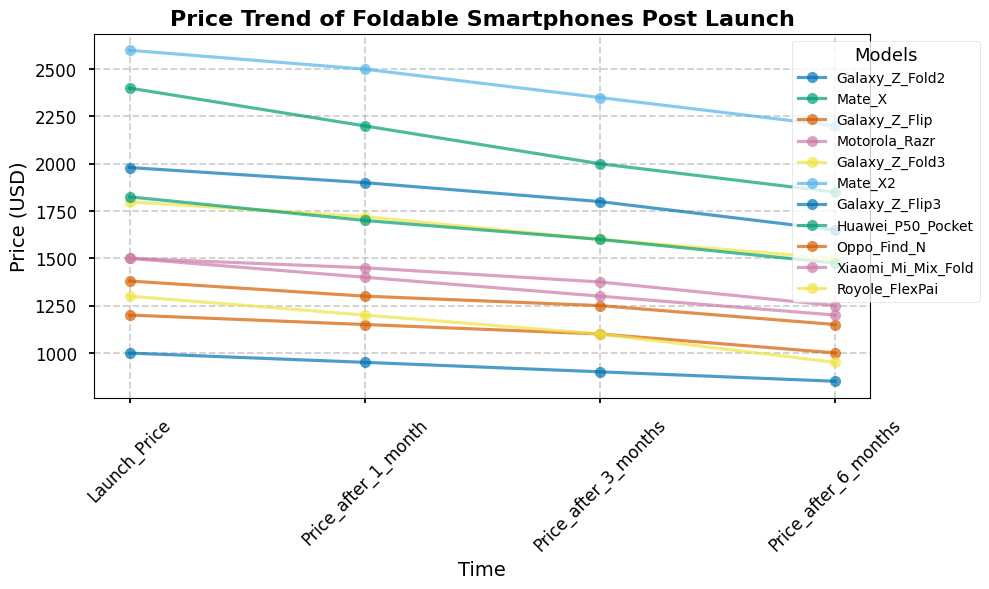Which model shows the highest initial launch price? Observe the launch price on the y-axis and find the model with the maximum value. In this case, "Mate X2" has the highest initial launch price at 2600 USD.
Answer: Mate X2 Comparing "Galaxy Z Fold2" and "Galaxy Z Fold3", which one shows a greater price decrease after 6 months? Calculate the difference in the launch price and price after 6 months for both models. "Galaxy Z Fold2" decreases from 1980 to 1650, a drop of 330 USD. "Galaxy Z Fold3" decreases from 1799 to 1500, a drop of 299 USD. Thus, "Galaxy Z Fold2" shows a greater price decrease.
Answer: Galaxy Z Fold2 What is the average price of "Motorola Razr" and "Royole FlexPai" after 3 months? Add the 3-month prices of both models and divide by 2. "Motorola Razr" is 1300 and "Royole FlexPai" is 1100; (1300 + 1100) / 2 = 1200 USD is the average price.
Answer: 1200 USD Which model exhibits the steepest price drop after 1 month? Determine the price drop for each model after 1 month and find the biggest value. "Mate X" drops from 2400 to 2200, a 200 USD decrease, which is one of the largest drops.
Answer: Mate X How does the price drop of "Oppo Find N" after 6 months compare to "Xiaomi Mi Mix Fold" after 6 months? Calculate the 6-month price drop for both models: "Oppo Find N" drops from 1200 to 1000 (200 USD) and "Xiaomi Mi Mix Fold" drops from 1500 to 1250 (250 USD). The drop for "Xiaomi Mi Mix Fold" is larger by 50 USD.
Answer: Xiaomi Mi Mix Fold By looking at the price trend, which model retains its value best after 6 months? The model that retains the highest percentage of its launch price after 6 months should be determined. "Mate X2" retains the most by dropping from 2600 to 2200, retaining approximately 84.6% of its launch price.
Answer: Mate X2 Between "Huawei P50 Pocket" and "Galaxy Z Flip3", which one has the higher price after 3 months? Observe the price after 3 months for both models: "Huawei P50 Pocket" is 1600 and "Galaxy Z Flip3" is 900; here, "Huawei P50 Pocket" has a higher price.
Answer: Huawei P50 Pocket What is the total price drop for "Galaxy Z Flip" from launch to after 6 months? Calculate the total drop by subtracting the 6-month price from the launch price of "Galaxy Z Flip": 1380 (launch price) - 1150 (6-month price) = 230 USD.
Answer: 230 USD Which model has a more constant decline in the price, "Mate X" or "Galaxy Z Fold3"? Compare the month-to-month price drops for both models to see which has smaller and more consistent changes. "Galaxy Z Fold3" shows drops of (79, 120, 100) and "Mate X" shows (200, 200, 150), indicating "Galaxy Z Fold3" has more consistent smaller drops.
Answer: Galaxy Z Fold3 